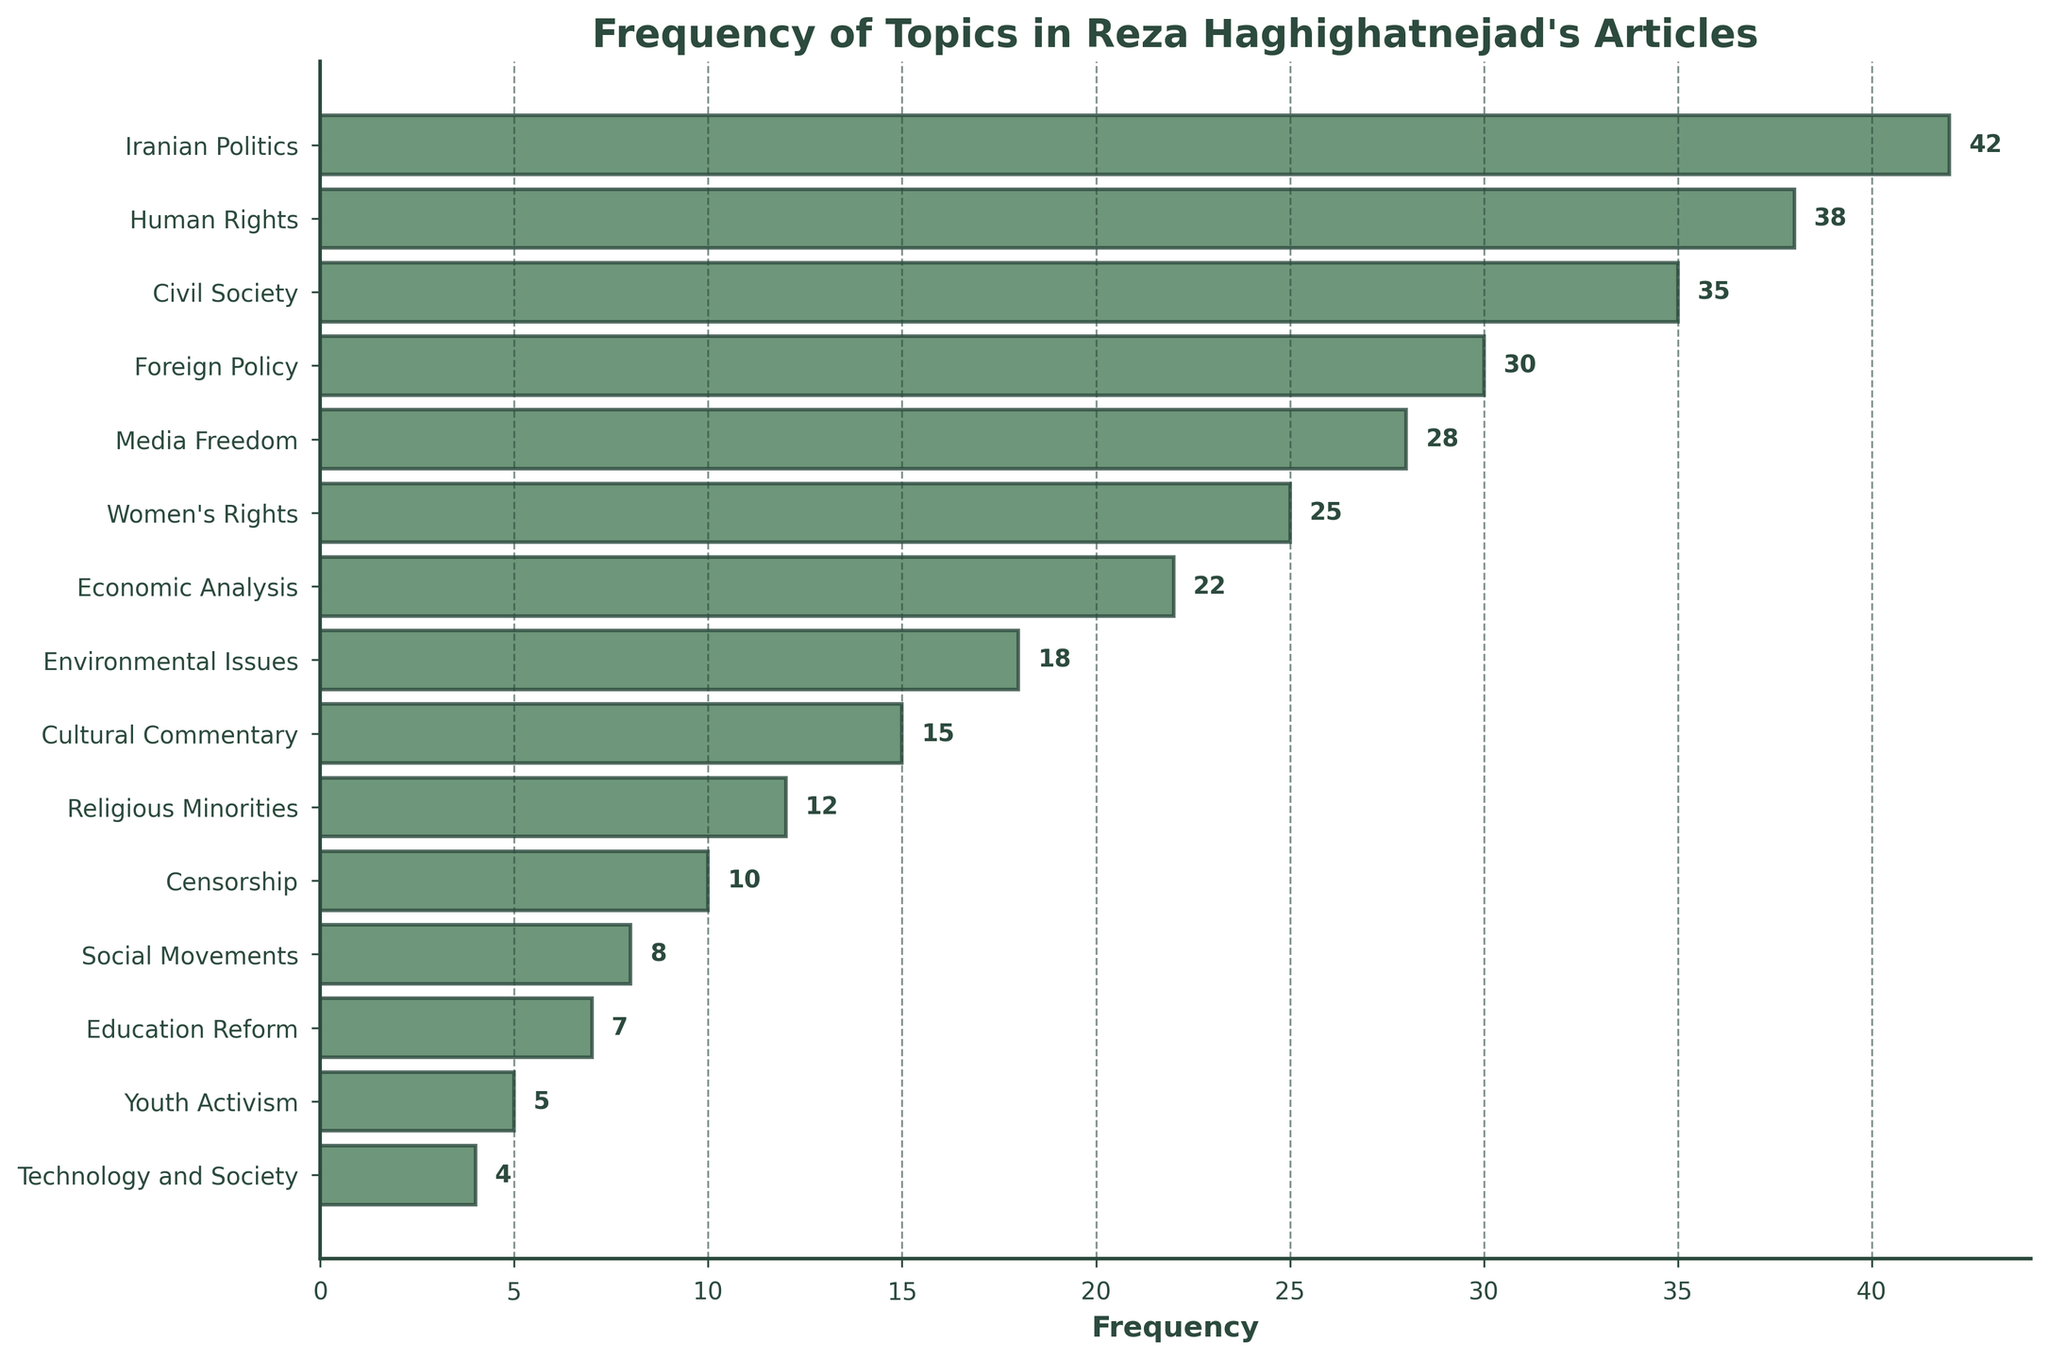Which topic has the highest frequency in Reza Haghighatnejad's articles? The chart shows bars representing different topics, with their lengths representing frequency. The longest bar corresponds to "Iranian Politics."
Answer: Iranian Politics How many topics have a frequency higher than 20? From the chart, locate and count the bars whose lengths correspond to frequencies greater than 20.
Answer: 7 What is the difference in frequency between "Human Rights" and "Technology and Society"? The frequency of "Human Rights" is 38, and "Technology and Society" is 4. Subtract 4 from 38.
Answer: 34 Which topics have a frequency exactly equal to 22? Locate the bar with a length corresponding to a frequency of 22. It corresponds to "Economic Analysis."
Answer: Economic Analysis What is the combined frequency of "Civil Society" and "Education Reform"? The frequency of "Civil Society" is 35, and "Education Reform" is 7. Add these values.
Answer: 42 What is the average frequency of "Women's Rights," "Economic Analysis," and "Environmental Issues"? Their frequencies are 25, 22, and 18, respectively. Sum them up (25 + 22 + 18 = 65) and divide by 3.
Answer: 21.67 Which topic has the lowest frequency, and what is its value? The shortest bar corresponds to "Technology and Society," which has a frequency of 4.
Answer: Technology and Society, 4 Are there more topics with a frequency less than or equal to 10 or more than 10? Count the bars with frequencies less than or equal to 10 (which are 4 topics) and those with frequencies greater than 10 (which are 11 topics). Compare the counts.
Answer: More than 10 How does the frequency of "Media Freedom" compare to that of "Environmental Issues"? The frequency of "Media Freedom" is 28, and "Environmental Issues" is 18. "Media Freedom" has a higher frequency.
Answer: Media Freedom has a higher frequency Is the frequency of "Religious Minorities" closer to "Censorship" or "Cultural Commentary"? The frequency of "Religious Minorities" is 12. "Censorship" is 10, and "Cultural Commentary" is 15. Calculate the differences: 12 - 10 = 2 and 15 - 12 = 3.
Answer: Censorship is closer 